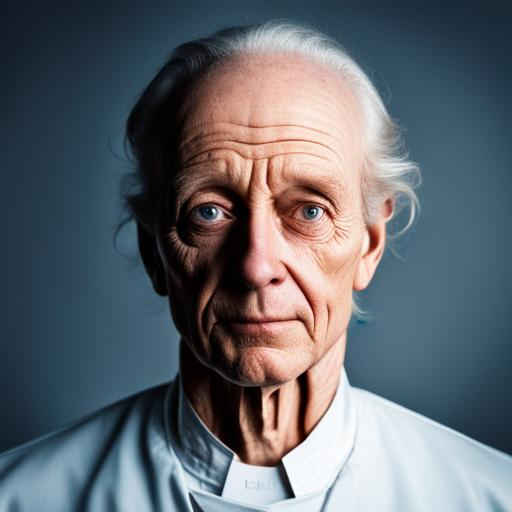Does the image have noise? The image is quite clear with minimal visible noise, which suggests it was taken with a high-quality camera and in good lighting conditions. 